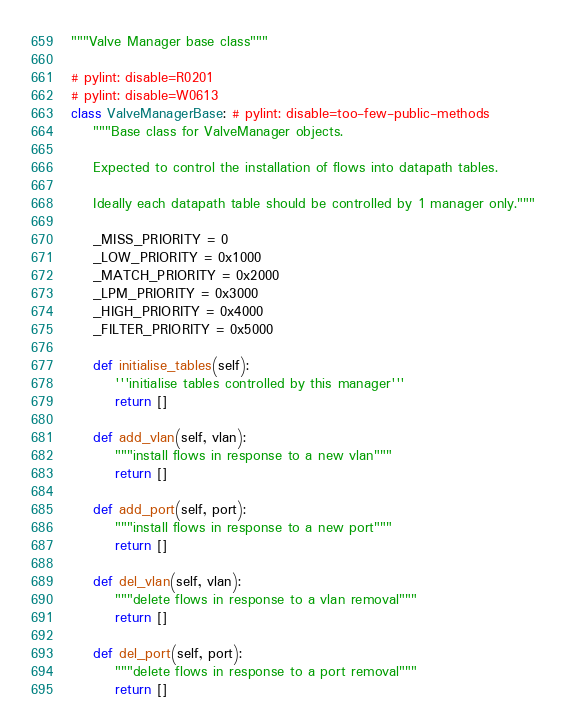Convert code to text. <code><loc_0><loc_0><loc_500><loc_500><_Python_>"""Valve Manager base class"""

# pylint: disable=R0201
# pylint: disable=W0613
class ValveManagerBase: # pylint: disable=too-few-public-methods
    """Base class for ValveManager objects.

    Expected to control the installation of flows into datapath tables.

    Ideally each datapath table should be controlled by 1 manager only."""

    _MISS_PRIORITY = 0
    _LOW_PRIORITY = 0x1000
    _MATCH_PRIORITY = 0x2000
    _LPM_PRIORITY = 0x3000
    _HIGH_PRIORITY = 0x4000
    _FILTER_PRIORITY = 0x5000

    def initialise_tables(self):
        '''initialise tables controlled by this manager'''
        return []

    def add_vlan(self, vlan):
        """install flows in response to a new vlan"""
        return []

    def add_port(self, port):
        """install flows in response to a new port"""
        return []

    def del_vlan(self, vlan):
        """delete flows in response to a vlan removal"""
        return []

    def del_port(self, port):
        """delete flows in response to a port removal"""
        return []
</code> 